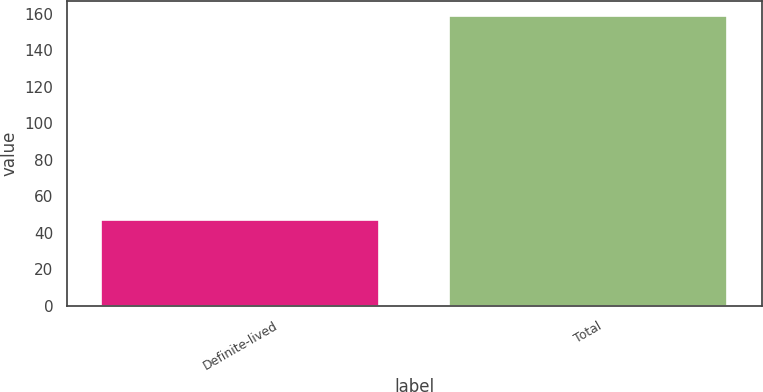<chart> <loc_0><loc_0><loc_500><loc_500><bar_chart><fcel>Definite-lived<fcel>Total<nl><fcel>47<fcel>159<nl></chart> 